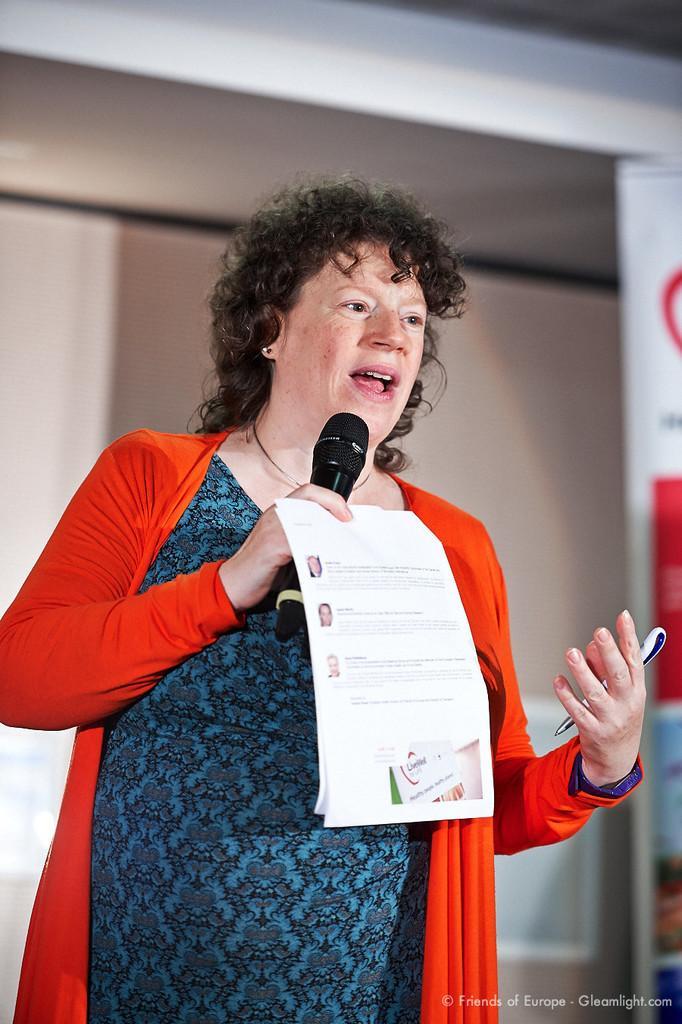In one or two sentences, can you explain what this image depicts? A lady with a blue dress and a red jacket holding a mic in her hand and a paper in her hand. In her another hand she is holding a pen and she is talking. 